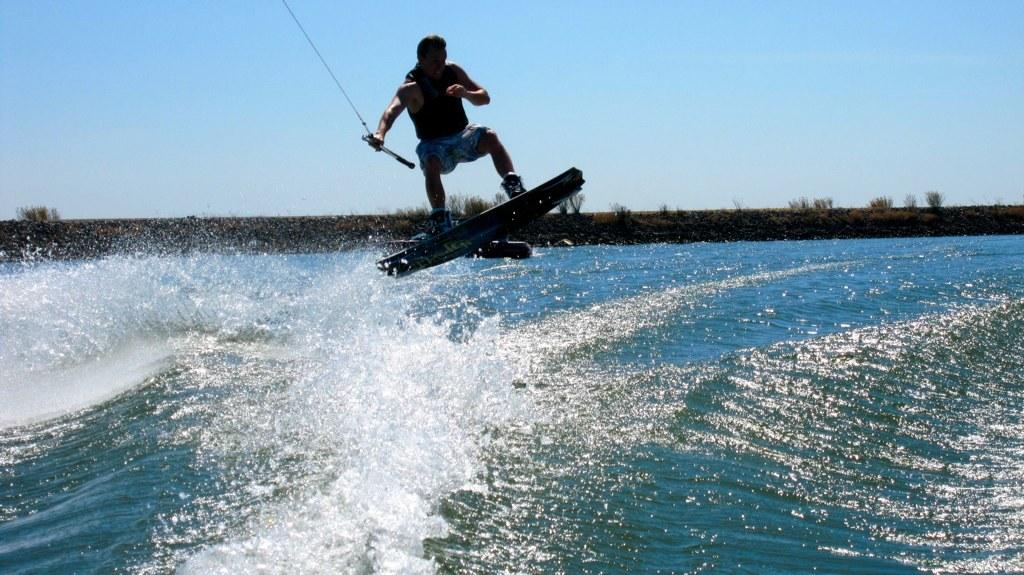What is the main subject of the image? There is a person in the image. What is the person doing in the image? The person is surfing on the water. What is the person holding in the image? The person is holding a rope with his hand. What is visible at the top of the image? There is a sky visible at the top of the image. How many fish can be seen swimming in the water with the person in the image? There are no fish visible in the image; it only shows a person surfing on the water. What type of class is the person attending in the image? There is no indication of a class or any educational setting in the image. 